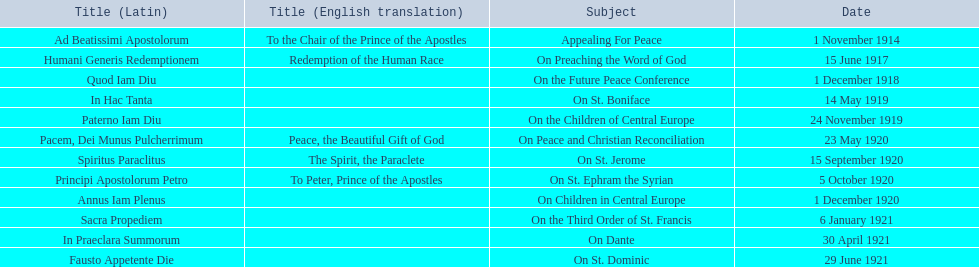What are all the subjects? Appealing For Peace, On Preaching the Word of God, On the Future Peace Conference, On St. Boniface, On the Children of Central Europe, On Peace and Christian Reconciliation, On St. Jerome, On St. Ephram the Syrian, On Children in Central Europe, On the Third Order of St. Francis, On Dante, On St. Dominic. Which occurred in 1920? On Peace and Christian Reconciliation, On St. Jerome, On St. Ephram the Syrian, On Children in Central Europe. Which occurred in may of that year? On Peace and Christian Reconciliation. 